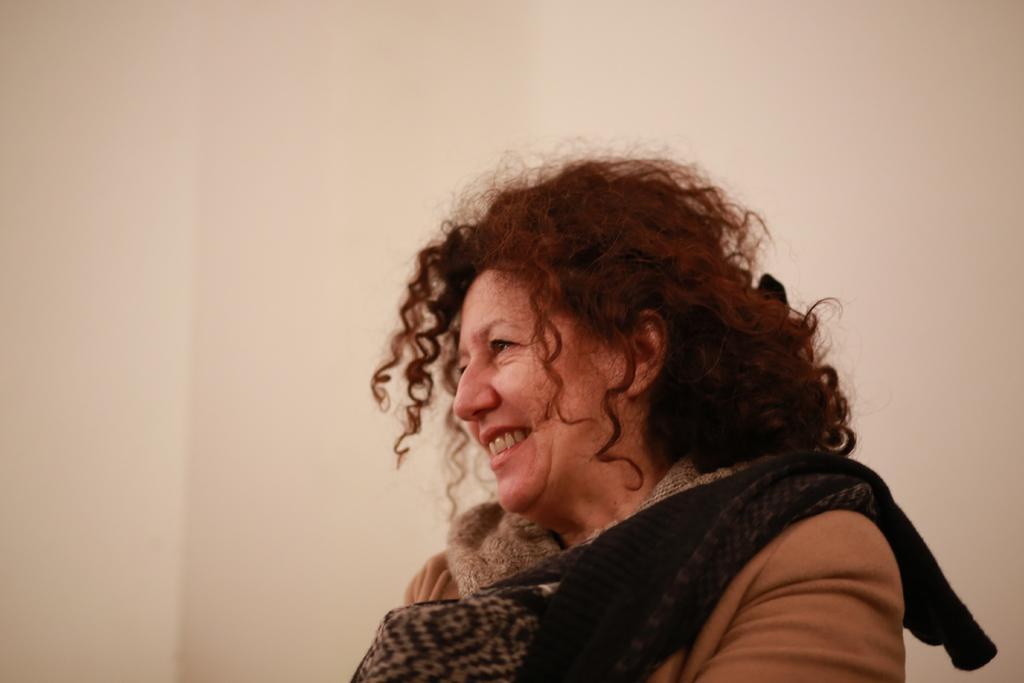Please provide a concise description of this image. In this image I can see a woman wearing brown colored jacket and I can see a black colored cloth on her. In the background I can see the cream colored surface. 